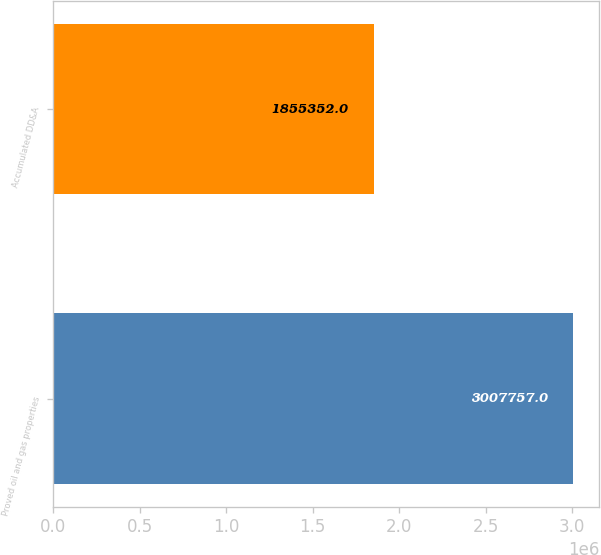Convert chart to OTSL. <chart><loc_0><loc_0><loc_500><loc_500><bar_chart><fcel>Proved oil and gas properties<fcel>Accumulated DD&A<nl><fcel>3.00776e+06<fcel>1.85535e+06<nl></chart> 